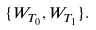Convert formula to latex. <formula><loc_0><loc_0><loc_500><loc_500>\{ W _ { T _ { 0 } } , W _ { T _ { 1 } } \} .</formula> 